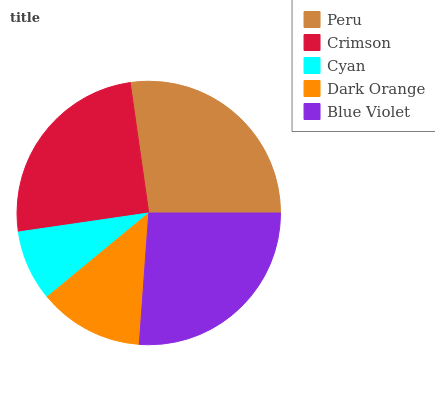Is Cyan the minimum?
Answer yes or no. Yes. Is Peru the maximum?
Answer yes or no. Yes. Is Crimson the minimum?
Answer yes or no. No. Is Crimson the maximum?
Answer yes or no. No. Is Peru greater than Crimson?
Answer yes or no. Yes. Is Crimson less than Peru?
Answer yes or no. Yes. Is Crimson greater than Peru?
Answer yes or no. No. Is Peru less than Crimson?
Answer yes or no. No. Is Crimson the high median?
Answer yes or no. Yes. Is Crimson the low median?
Answer yes or no. Yes. Is Blue Violet the high median?
Answer yes or no. No. Is Blue Violet the low median?
Answer yes or no. No. 